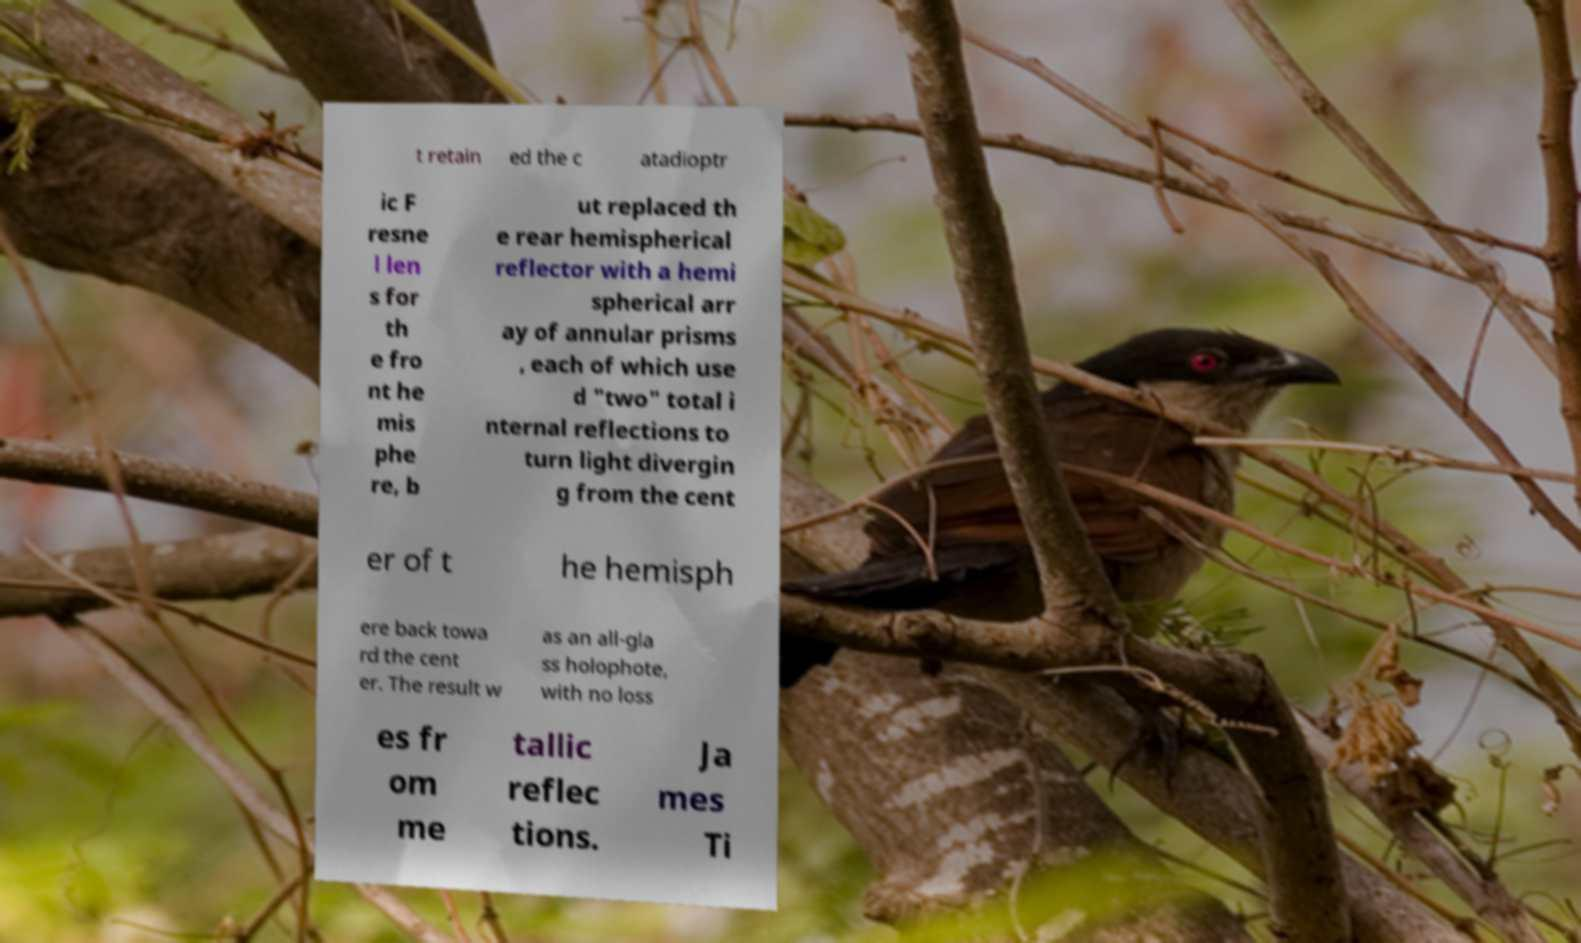Can you accurately transcribe the text from the provided image for me? t retain ed the c atadioptr ic F resne l len s for th e fro nt he mis phe re, b ut replaced th e rear hemispherical reflector with a hemi spherical arr ay of annular prisms , each of which use d "two" total i nternal reflections to turn light divergin g from the cent er of t he hemisph ere back towa rd the cent er. The result w as an all-gla ss holophote, with no loss es fr om me tallic reflec tions. Ja mes Ti 